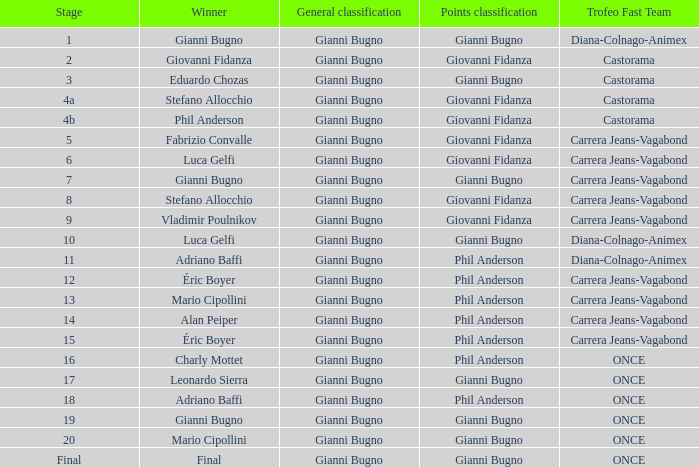Who is the trofeo fast team in stage 10? Diana-Colnago-Animex. 